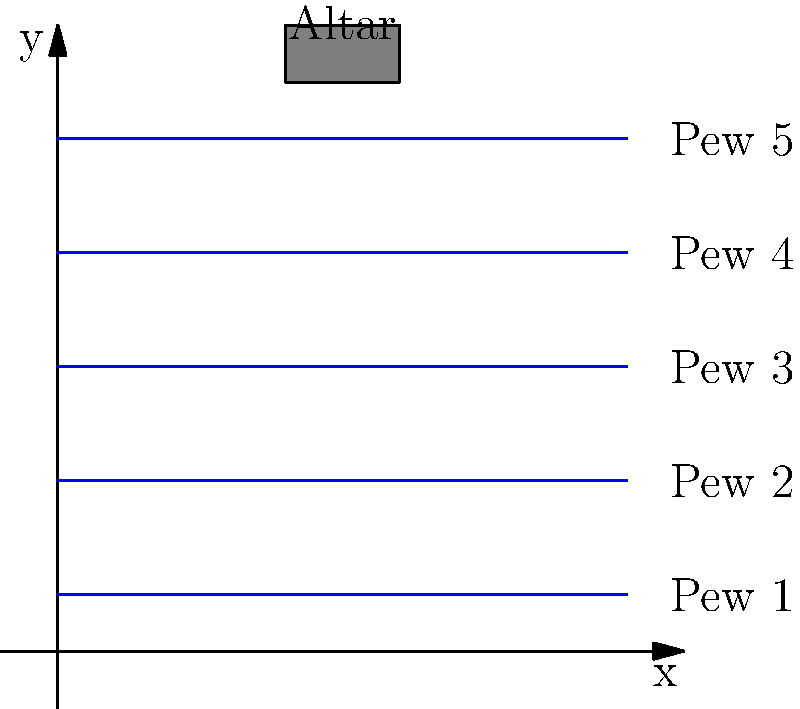In planning the seating arrangement for your church sanctuary, you've decided to use a coordinate system to optimize space. The sanctuary is represented by a 10x10 unit grid, with the altar located at the top center. Five pews, each 10 units long, are placed parallel to the x-axis at y-coordinates 1, 3, 5, 7, and 9. If each unit of pew length can seat 2 people, what is the total seating capacity of the sanctuary? To solve this problem, let's follow these steps:

1. Identify the number of pews:
   There are 5 pews in total, placed at y-coordinates 1, 3, 5, 7, and 9.

2. Calculate the length of each pew:
   Each pew spans the entire width of the sanctuary, which is 10 units.

3. Determine the seating capacity per unit length:
   We're told that each unit of pew length can seat 2 people.

4. Calculate the seating capacity for one pew:
   Capacity per pew = Length of pew × People per unit
   $$ \text{Capacity per pew} = 10 \times 2 = 20 \text{ people} $$

5. Calculate the total seating capacity:
   Total capacity = Number of pews × Capacity per pew
   $$ \text{Total capacity} = 5 \times 20 = 100 \text{ people} $$

Therefore, the total seating capacity of the sanctuary is 100 people.
Answer: 100 people 